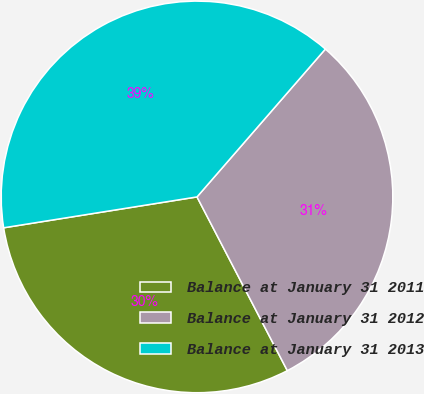Convert chart. <chart><loc_0><loc_0><loc_500><loc_500><pie_chart><fcel>Balance at January 31 2011<fcel>Balance at January 31 2012<fcel>Balance at January 31 2013<nl><fcel>30.11%<fcel>30.99%<fcel>38.9%<nl></chart> 